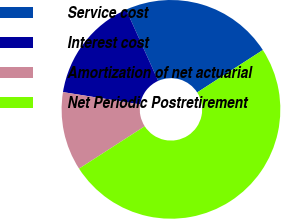Convert chart to OTSL. <chart><loc_0><loc_0><loc_500><loc_500><pie_chart><fcel>Service cost<fcel>Interest cost<fcel>Amortization of net actuarial<fcel>Net Periodic Postretirement<nl><fcel>22.6%<fcel>15.75%<fcel>11.64%<fcel>50.0%<nl></chart> 